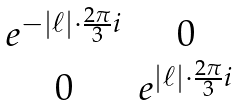<formula> <loc_0><loc_0><loc_500><loc_500>\begin{matrix} e ^ { - | \ell | \cdot \frac { 2 \pi } { 3 } i } & 0 \\ 0 & e ^ { | \ell | \cdot \frac { 2 \pi } { 3 } i } \end{matrix}</formula> 